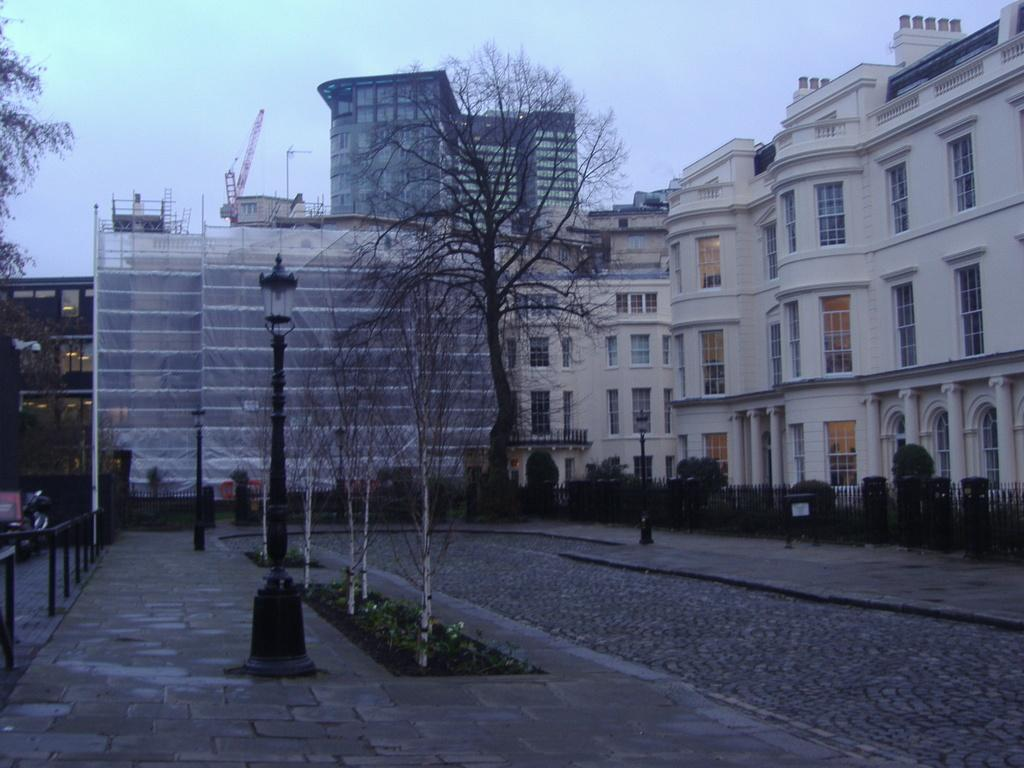What type of structures can be seen in the image? There are buildings in the image. What other natural elements are present in the image? There are trees in the image. What type of lighting is present in the image? There is a street lamp in the image. What is visible at the top of the image? The sky is visible at the top of the image. How many eggs are visible in the image? There are no eggs present in the image. What color is the orange in the image? There is no orange present in the image. 